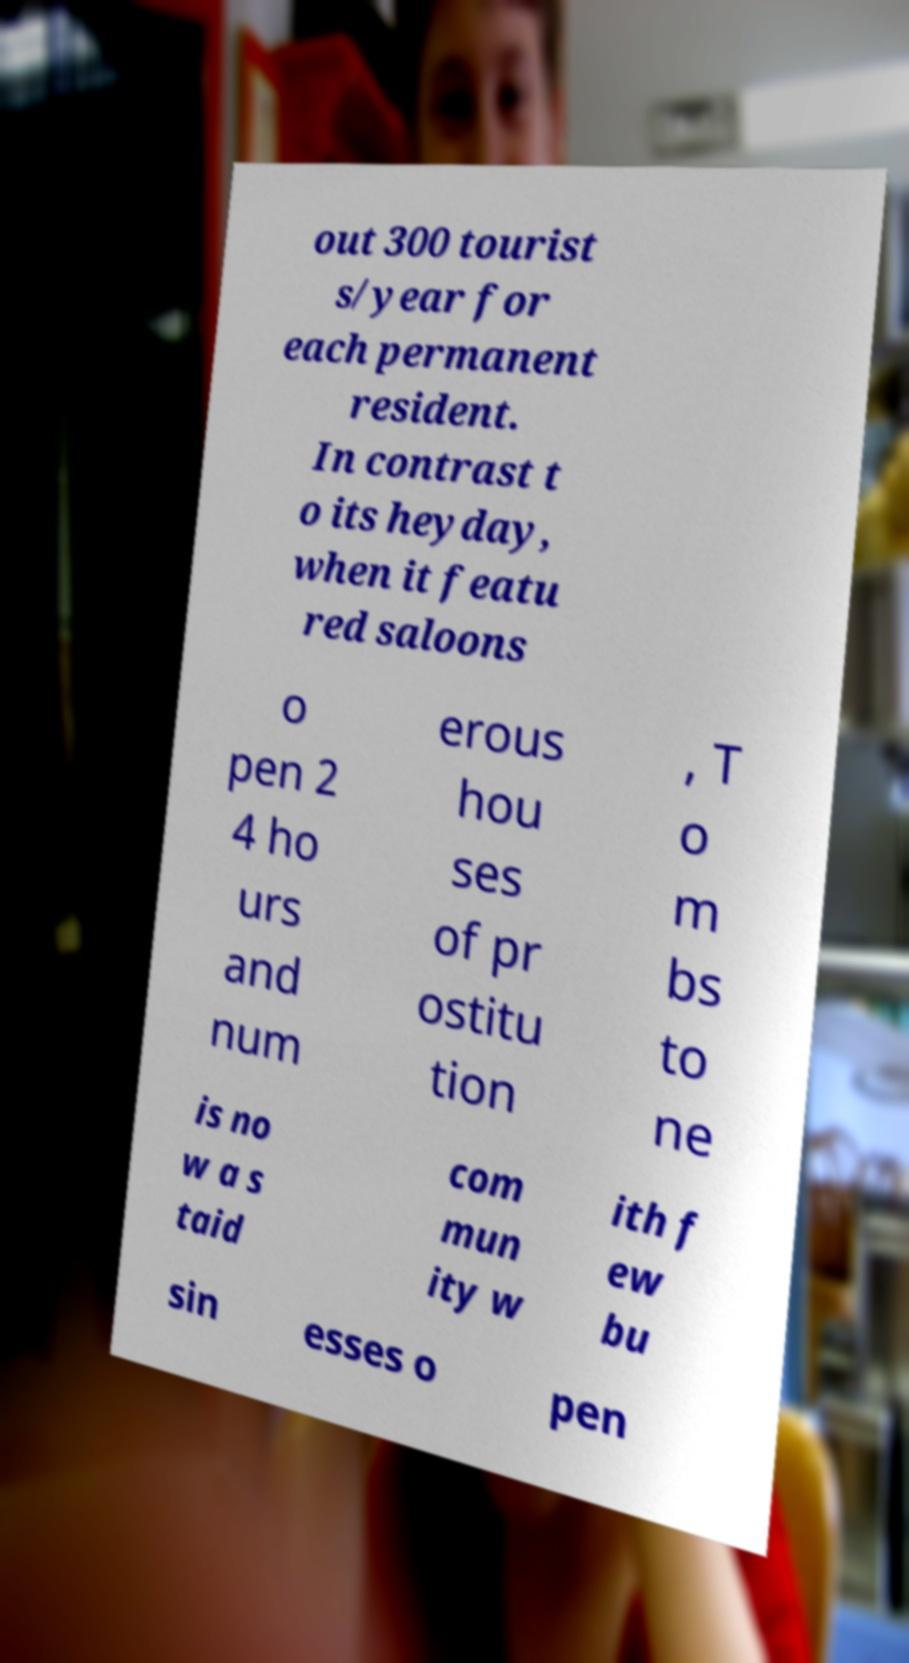I need the written content from this picture converted into text. Can you do that? out 300 tourist s/year for each permanent resident. In contrast t o its heyday, when it featu red saloons o pen 2 4 ho urs and num erous hou ses of pr ostitu tion , T o m bs to ne is no w a s taid com mun ity w ith f ew bu sin esses o pen 